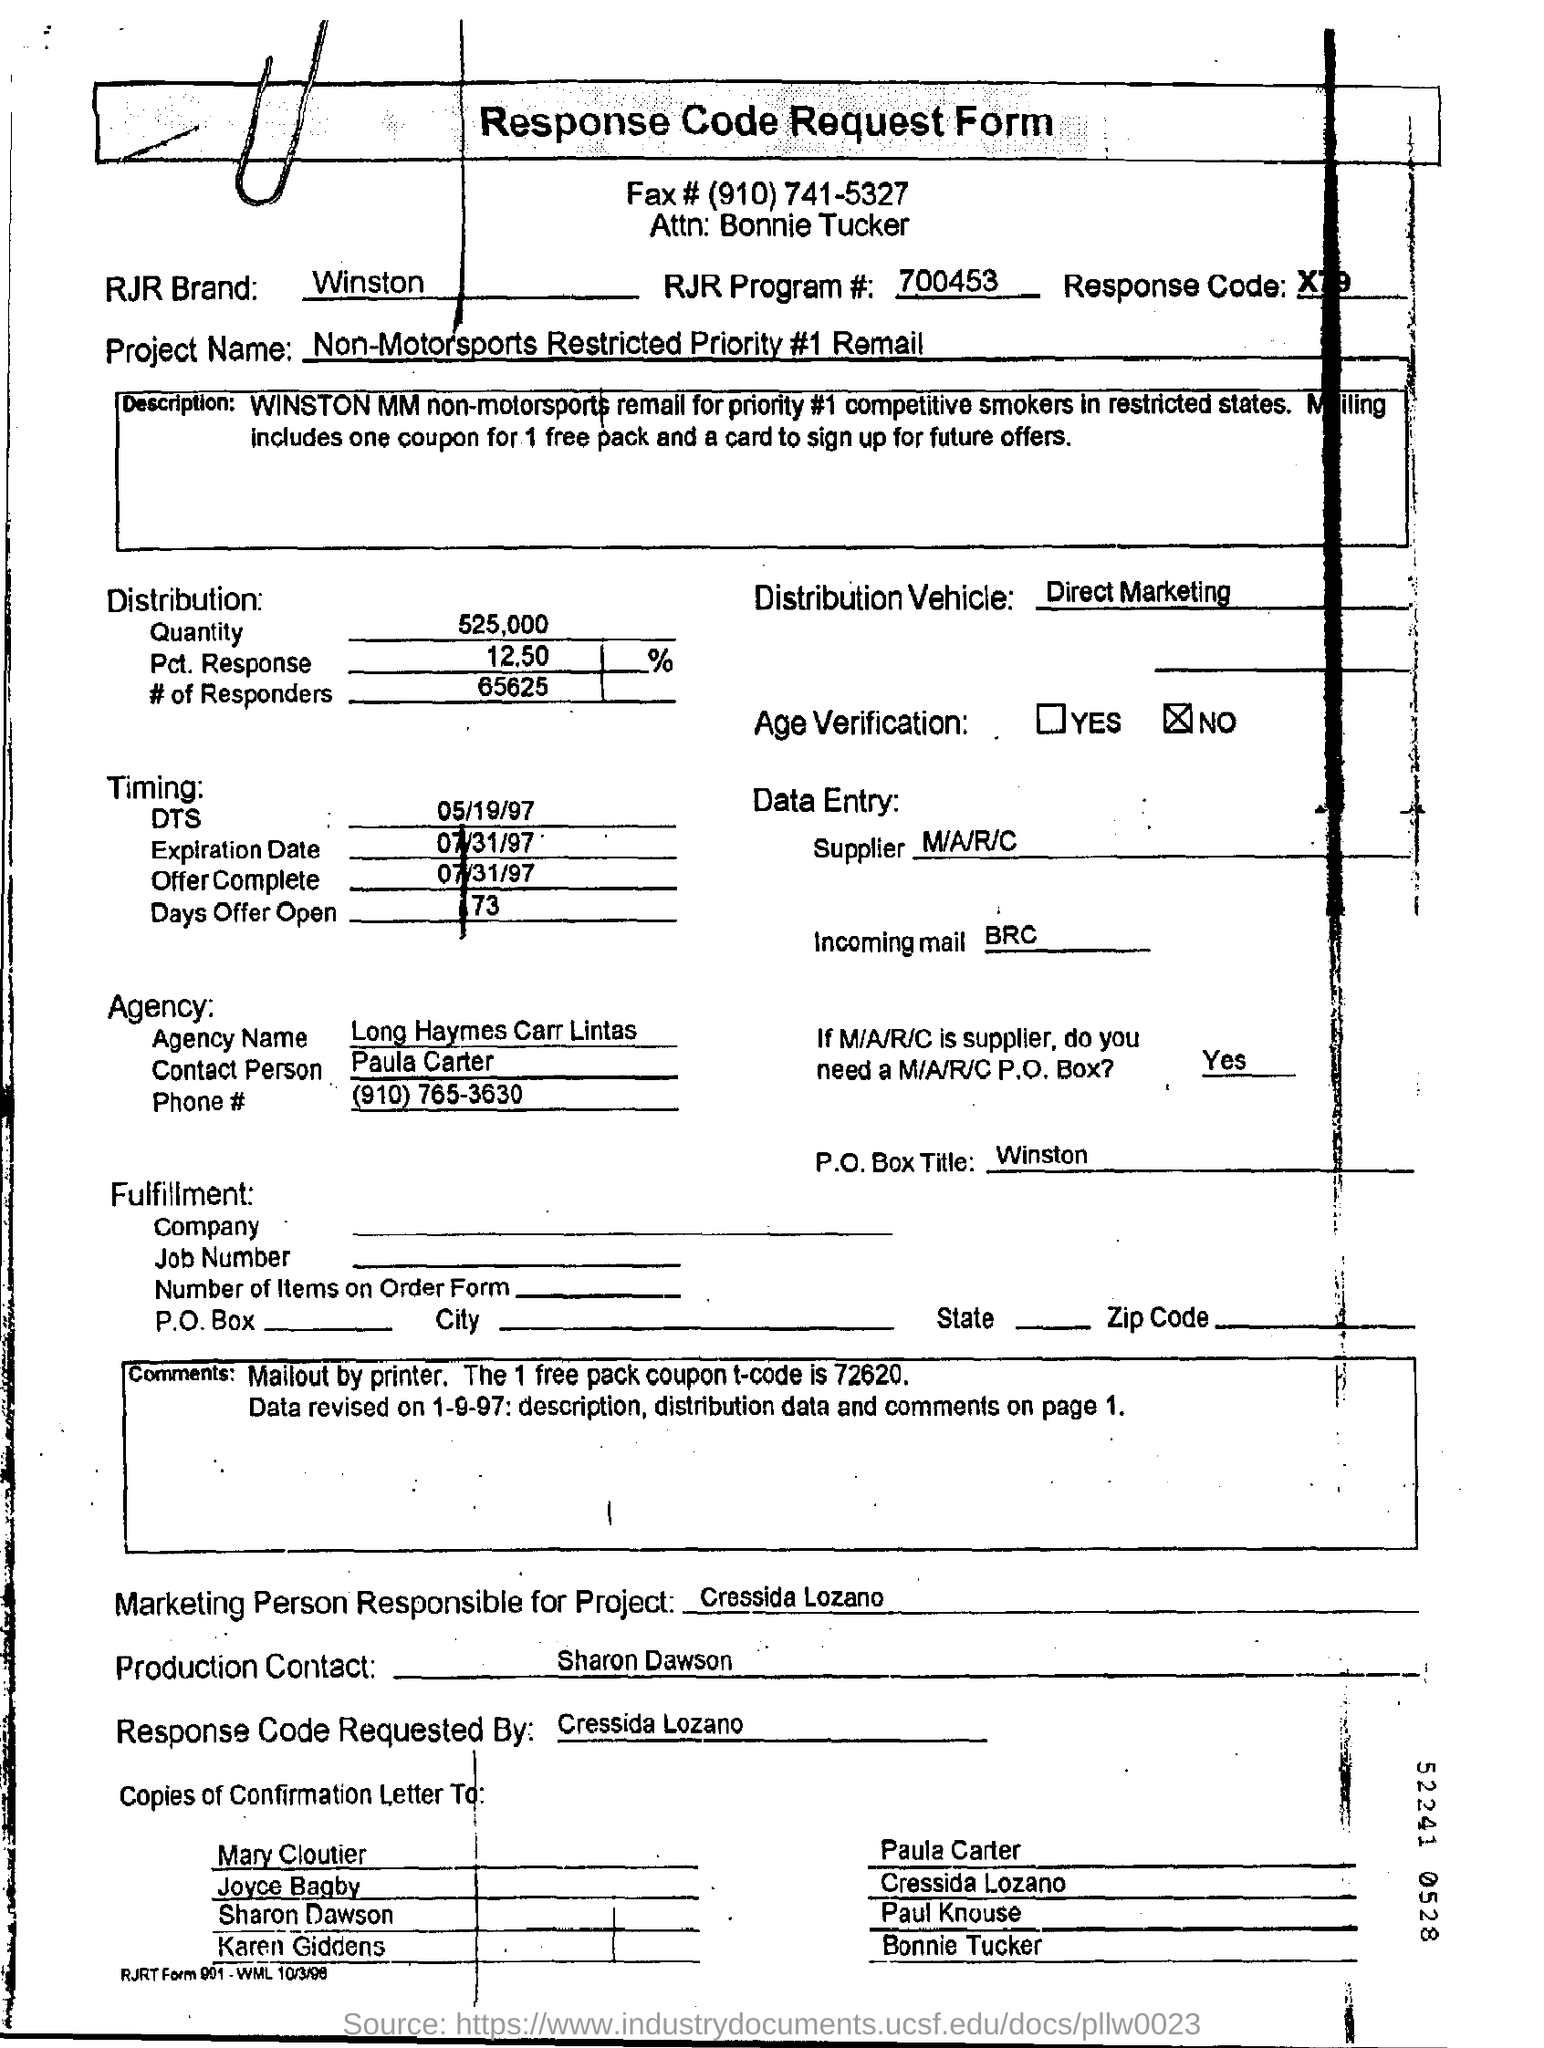List a handful of essential elements in this visual. The supplier is M/A/R/C... The RJR Program Number is 700453.. The expiration date is July 31st, 1997. The message being written in the Incoming Mail field contains the text "BRC..". The Production Contact Field mentions Sharon Dawson. 